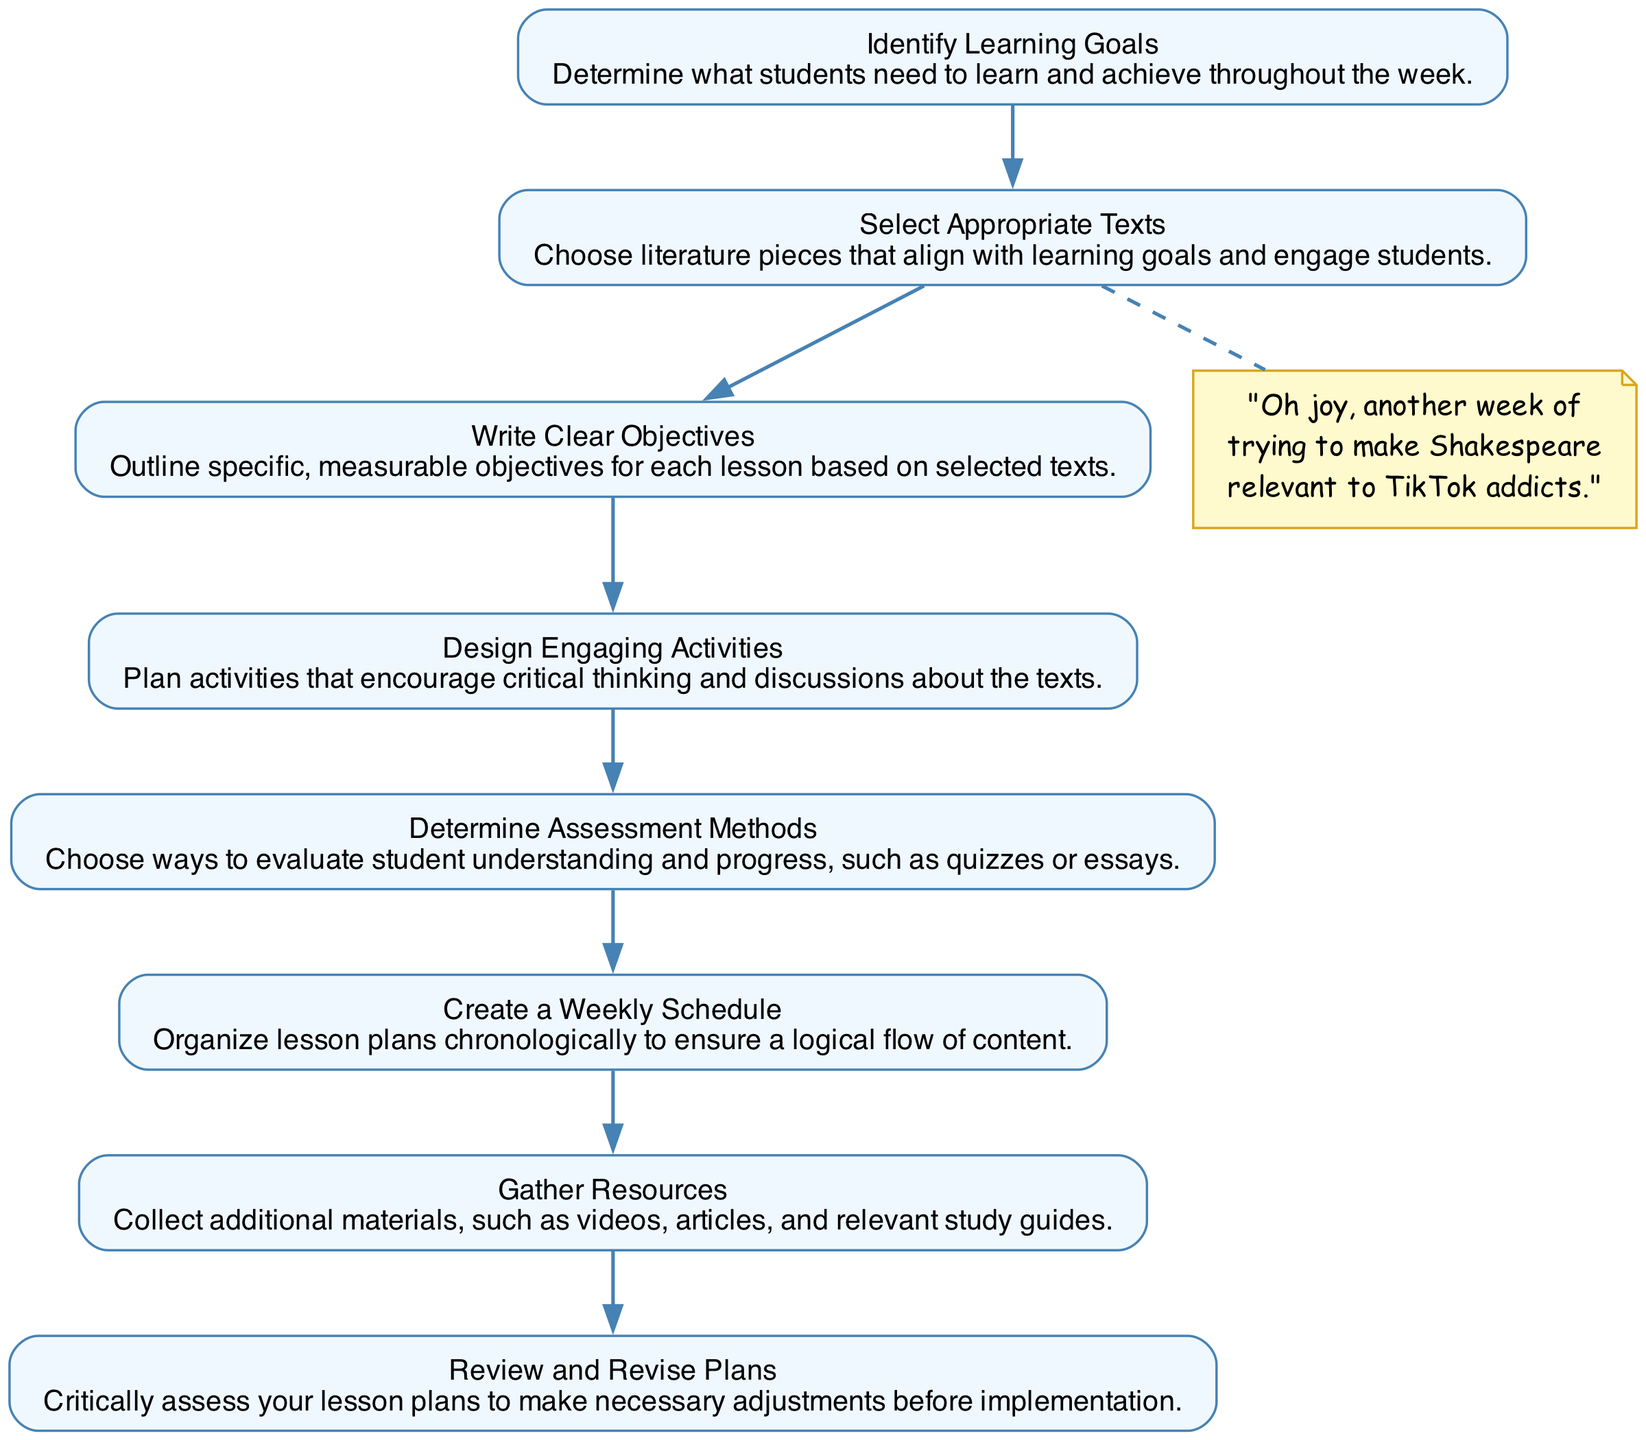What is the first step in the lesson planning process? The first step is "Identify Learning Goals," which sets the foundation for what students need to learn during the week.
Answer: Identify Learning Goals How many steps are there in the lesson planning process? The diagram outlines a total of 8 steps in the lesson planning process, from identifying learning goals to revising plans.
Answer: 8 Which step involves selecting literature pieces? The step that involves selecting literature pieces is "Select Appropriate Texts," ensuring alignment with the learning goals.
Answer: Select Appropriate Texts What is the last step mentioned in the diagram? The last step in the diagram is "Review and Revise Plans," which emphasizes assessing lesson plans before implementation.
Answer: Review and Revise Plans Which step is directly linked to evaluating student progress? The step linked directly to evaluating student progress is "Determine Assessment Methods," where different evaluation techniques are chosen.
Answer: Determine Assessment Methods What is the relationship between designing activities and determining assessment methods? Designing activities occurs before determining assessment methods, as effective assessment requires understanding the activities implemented in the lessons.
Answer: Designing activities comes before assessing Which node contains a snarky comment? The node with the snarky comment is linked to the step "Select Appropriate Texts," highlighting frustration with making classics relevant.
Answer: Select Appropriate Texts What type of activities should be designed according to the diagram? The activities to be designed are described as "Engaging Activities," intended to encourage critical thinking and discussions about the texts.
Answer: Engaging Activities 